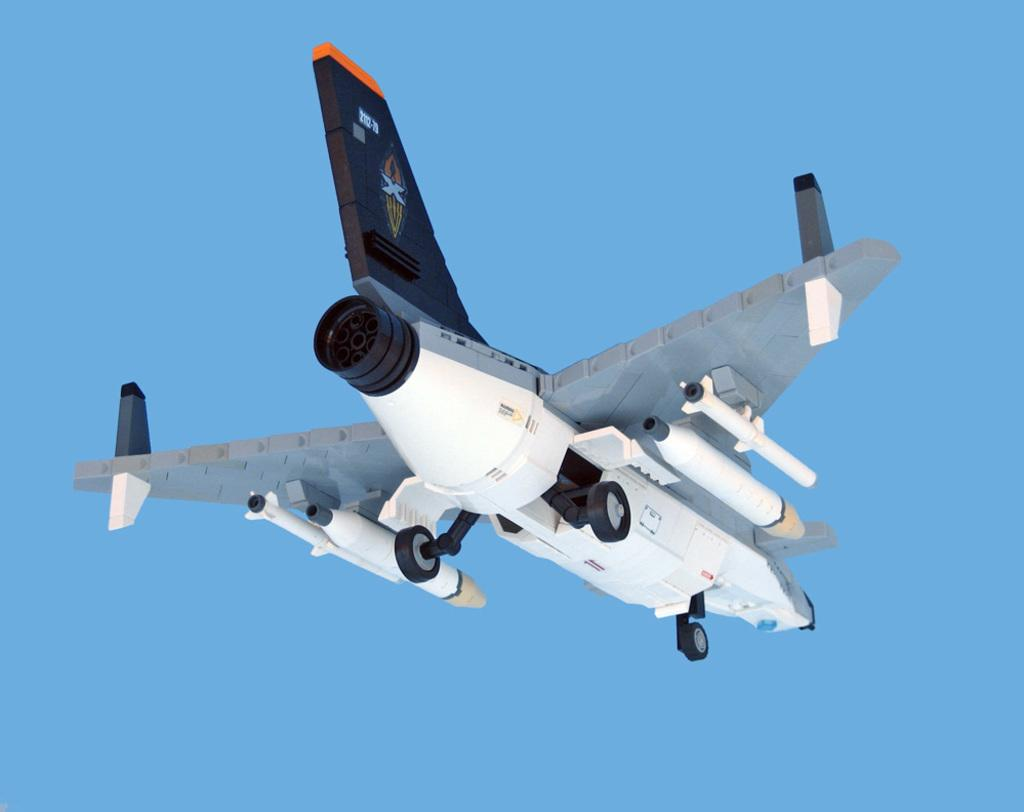What is the main subject of the image? There is an aircraft in the image. What color is the background of the image? The background of the image is blue. Can you see a snail crawling on the aircraft in the image? No, there is no snail present on the aircraft in the image. 